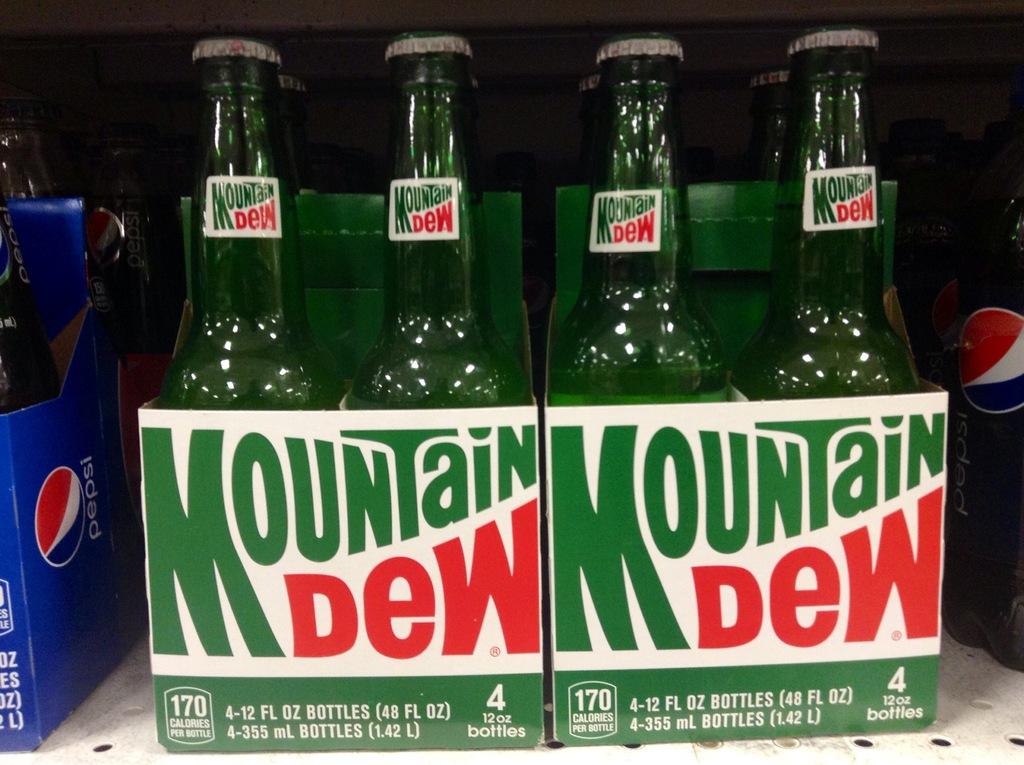What is the brand of the soda?
Keep it short and to the point. Mountain dew. How many bottles are in each case?
Offer a terse response. 4. 